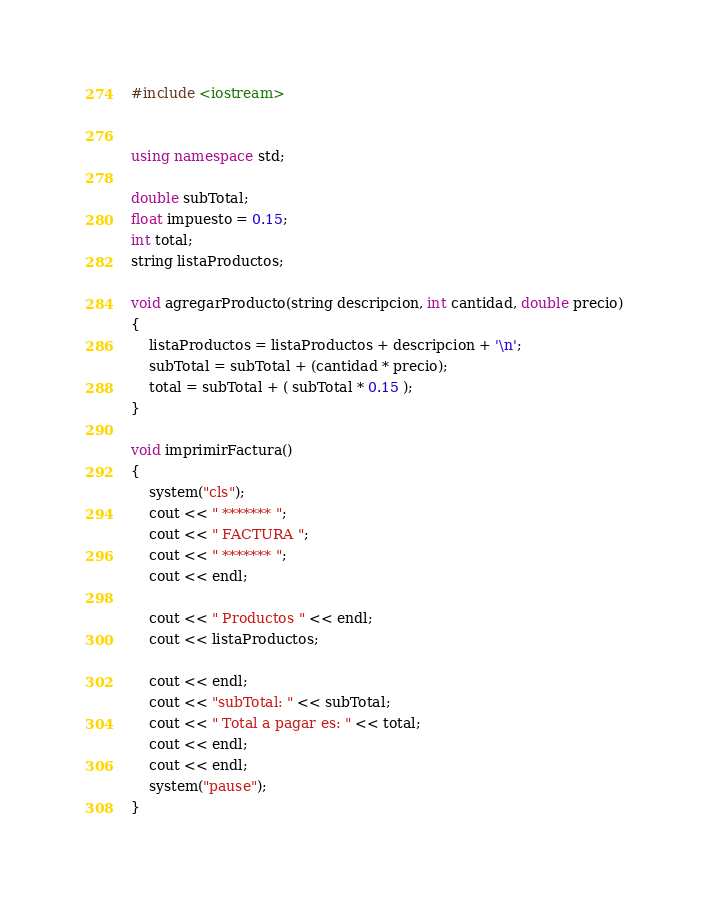Convert code to text. <code><loc_0><loc_0><loc_500><loc_500><_C++_>

#include <iostream>


using namespace std;

double subTotal;
float impuesto = 0.15;
int total;
string listaProductos;

void agregarProducto(string descripcion, int cantidad, double precio)
{
	listaProductos = listaProductos + descripcion + '\n';
	subTotal = subTotal + (cantidad * precio);
	total = subTotal + ( subTotal * 0.15 );
}

void imprimirFactura()
{
	system("cls");
	cout << " ******* ";
	cout << " FACTURA ";
	cout << " ******* ";
	cout << endl;
	
	cout << " Productos " << endl;
	cout << listaProductos;
	
	cout << endl;
	cout << "subTotal: " << subTotal;
	cout << " Total a pagar es: " << total;
	cout << endl;
	cout << endl;
	system("pause");
}
</code> 